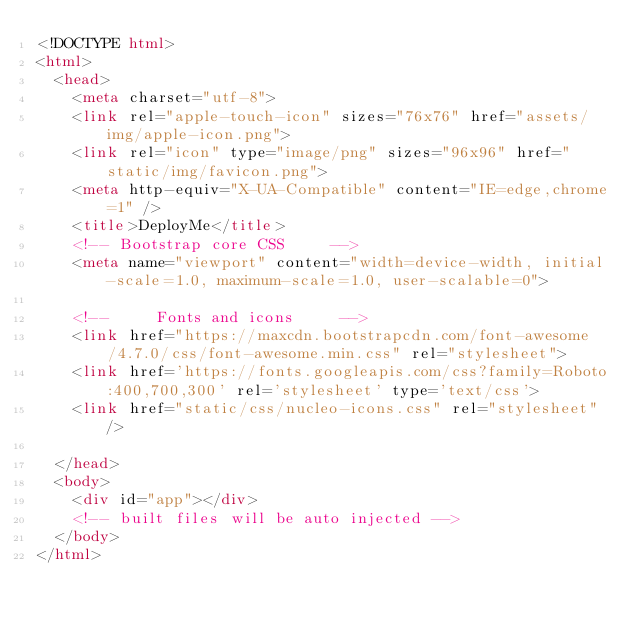<code> <loc_0><loc_0><loc_500><loc_500><_HTML_><!DOCTYPE html>
<html>
  <head>
    <meta charset="utf-8">
    <link rel="apple-touch-icon" sizes="76x76" href="assets/img/apple-icon.png">
    <link rel="icon" type="image/png" sizes="96x96" href="static/img/favicon.png">
    <meta http-equiv="X-UA-Compatible" content="IE=edge,chrome=1" />
    <title>DeployMe</title>
    <!-- Bootstrap core CSS     -->
    <meta name="viewport" content="width=device-width, initial-scale=1.0, maximum-scale=1.0, user-scalable=0">

    <!--     Fonts and icons     -->
    <link href="https://maxcdn.bootstrapcdn.com/font-awesome/4.7.0/css/font-awesome.min.css" rel="stylesheet">
    <link href='https://fonts.googleapis.com/css?family=Roboto:400,700,300' rel='stylesheet' type='text/css'>
    <link href="static/css/nucleo-icons.css" rel="stylesheet" />

  </head>
  <body>
    <div id="app"></div>
    <!-- built files will be auto injected -->
  </body>
</html>
</code> 